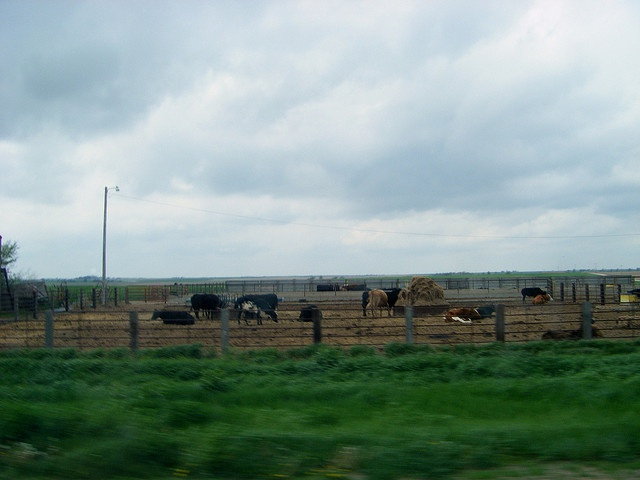Describe the objects in this image and their specific colors. I can see cow in darkgray, black, gray, and darkgreen tones, cow in darkgray, black, and gray tones, cow in darkgray, black, gray, and teal tones, cow in darkgray, black, and gray tones, and cow in darkgray, black, and gray tones in this image. 